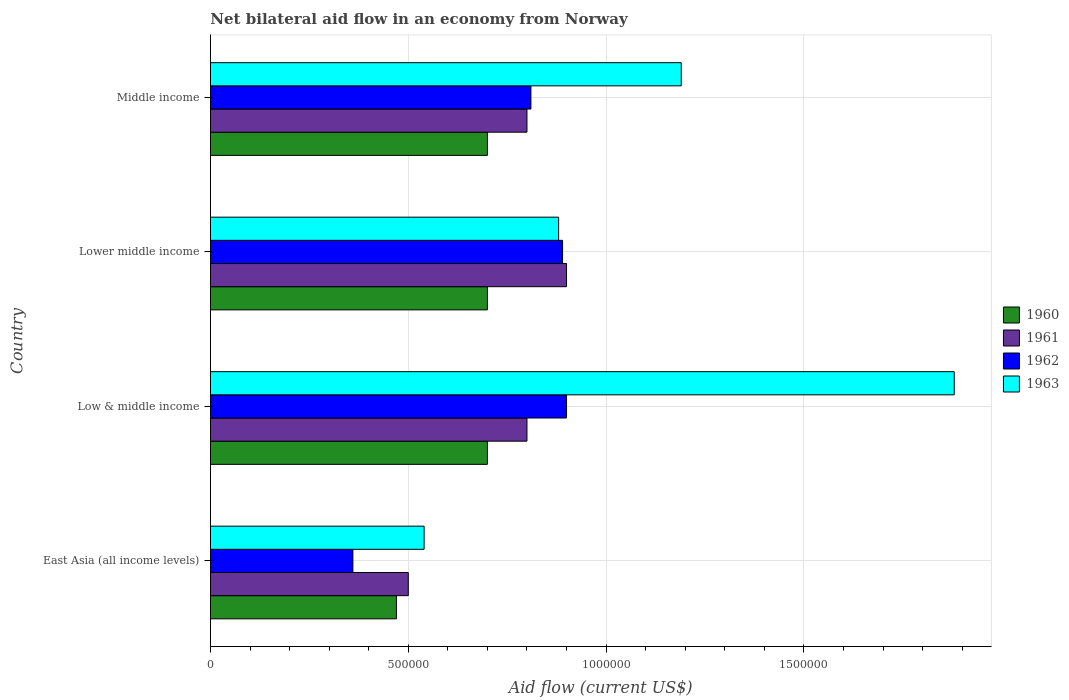How many groups of bars are there?
Offer a terse response. 4. How many bars are there on the 3rd tick from the top?
Ensure brevity in your answer.  4. What is the label of the 2nd group of bars from the top?
Provide a succinct answer. Lower middle income. In which country was the net bilateral aid flow in 1960 maximum?
Offer a terse response. Low & middle income. In which country was the net bilateral aid flow in 1960 minimum?
Give a very brief answer. East Asia (all income levels). What is the total net bilateral aid flow in 1960 in the graph?
Your response must be concise. 2.57e+06. What is the difference between the net bilateral aid flow in 1961 in East Asia (all income levels) and that in Middle income?
Give a very brief answer. -3.00e+05. What is the difference between the net bilateral aid flow in 1963 in Middle income and the net bilateral aid flow in 1961 in Low & middle income?
Offer a very short reply. 3.90e+05. What is the average net bilateral aid flow in 1960 per country?
Your answer should be compact. 6.42e+05. What is the difference between the net bilateral aid flow in 1960 and net bilateral aid flow in 1961 in Lower middle income?
Your answer should be very brief. -2.00e+05. What is the ratio of the net bilateral aid flow in 1963 in Low & middle income to that in Middle income?
Keep it short and to the point. 1.58. Is the difference between the net bilateral aid flow in 1960 in East Asia (all income levels) and Lower middle income greater than the difference between the net bilateral aid flow in 1961 in East Asia (all income levels) and Lower middle income?
Your response must be concise. Yes. What is the difference between the highest and the lowest net bilateral aid flow in 1961?
Make the answer very short. 4.00e+05. Is the sum of the net bilateral aid flow in 1963 in East Asia (all income levels) and Lower middle income greater than the maximum net bilateral aid flow in 1961 across all countries?
Offer a terse response. Yes. What does the 3rd bar from the top in East Asia (all income levels) represents?
Ensure brevity in your answer.  1961. Is it the case that in every country, the sum of the net bilateral aid flow in 1962 and net bilateral aid flow in 1963 is greater than the net bilateral aid flow in 1960?
Keep it short and to the point. Yes. How many bars are there?
Give a very brief answer. 16. How many countries are there in the graph?
Your answer should be compact. 4. Does the graph contain any zero values?
Ensure brevity in your answer.  No. Does the graph contain grids?
Offer a terse response. Yes. What is the title of the graph?
Your answer should be compact. Net bilateral aid flow in an economy from Norway. Does "2002" appear as one of the legend labels in the graph?
Provide a short and direct response. No. What is the label or title of the X-axis?
Give a very brief answer. Aid flow (current US$). What is the label or title of the Y-axis?
Keep it short and to the point. Country. What is the Aid flow (current US$) of 1962 in East Asia (all income levels)?
Offer a very short reply. 3.60e+05. What is the Aid flow (current US$) in 1963 in East Asia (all income levels)?
Give a very brief answer. 5.40e+05. What is the Aid flow (current US$) of 1961 in Low & middle income?
Offer a terse response. 8.00e+05. What is the Aid flow (current US$) of 1963 in Low & middle income?
Keep it short and to the point. 1.88e+06. What is the Aid flow (current US$) of 1960 in Lower middle income?
Make the answer very short. 7.00e+05. What is the Aid flow (current US$) in 1962 in Lower middle income?
Ensure brevity in your answer.  8.90e+05. What is the Aid flow (current US$) of 1963 in Lower middle income?
Your answer should be very brief. 8.80e+05. What is the Aid flow (current US$) in 1960 in Middle income?
Your response must be concise. 7.00e+05. What is the Aid flow (current US$) of 1962 in Middle income?
Offer a very short reply. 8.10e+05. What is the Aid flow (current US$) of 1963 in Middle income?
Offer a terse response. 1.19e+06. Across all countries, what is the maximum Aid flow (current US$) in 1962?
Provide a short and direct response. 9.00e+05. Across all countries, what is the maximum Aid flow (current US$) of 1963?
Provide a short and direct response. 1.88e+06. Across all countries, what is the minimum Aid flow (current US$) of 1961?
Provide a short and direct response. 5.00e+05. Across all countries, what is the minimum Aid flow (current US$) in 1963?
Your answer should be very brief. 5.40e+05. What is the total Aid flow (current US$) of 1960 in the graph?
Offer a terse response. 2.57e+06. What is the total Aid flow (current US$) of 1962 in the graph?
Your answer should be compact. 2.96e+06. What is the total Aid flow (current US$) in 1963 in the graph?
Give a very brief answer. 4.49e+06. What is the difference between the Aid flow (current US$) in 1961 in East Asia (all income levels) and that in Low & middle income?
Give a very brief answer. -3.00e+05. What is the difference between the Aid flow (current US$) of 1962 in East Asia (all income levels) and that in Low & middle income?
Give a very brief answer. -5.40e+05. What is the difference between the Aid flow (current US$) in 1963 in East Asia (all income levels) and that in Low & middle income?
Make the answer very short. -1.34e+06. What is the difference between the Aid flow (current US$) in 1960 in East Asia (all income levels) and that in Lower middle income?
Ensure brevity in your answer.  -2.30e+05. What is the difference between the Aid flow (current US$) in 1961 in East Asia (all income levels) and that in Lower middle income?
Give a very brief answer. -4.00e+05. What is the difference between the Aid flow (current US$) in 1962 in East Asia (all income levels) and that in Lower middle income?
Offer a terse response. -5.30e+05. What is the difference between the Aid flow (current US$) in 1963 in East Asia (all income levels) and that in Lower middle income?
Make the answer very short. -3.40e+05. What is the difference between the Aid flow (current US$) of 1962 in East Asia (all income levels) and that in Middle income?
Your answer should be compact. -4.50e+05. What is the difference between the Aid flow (current US$) of 1963 in East Asia (all income levels) and that in Middle income?
Make the answer very short. -6.50e+05. What is the difference between the Aid flow (current US$) in 1961 in Low & middle income and that in Lower middle income?
Your answer should be compact. -1.00e+05. What is the difference between the Aid flow (current US$) in 1962 in Low & middle income and that in Lower middle income?
Your response must be concise. 10000. What is the difference between the Aid flow (current US$) in 1963 in Low & middle income and that in Lower middle income?
Offer a very short reply. 1.00e+06. What is the difference between the Aid flow (current US$) of 1961 in Low & middle income and that in Middle income?
Make the answer very short. 0. What is the difference between the Aid flow (current US$) of 1963 in Low & middle income and that in Middle income?
Your answer should be compact. 6.90e+05. What is the difference between the Aid flow (current US$) of 1960 in Lower middle income and that in Middle income?
Keep it short and to the point. 0. What is the difference between the Aid flow (current US$) in 1961 in Lower middle income and that in Middle income?
Your answer should be compact. 1.00e+05. What is the difference between the Aid flow (current US$) of 1962 in Lower middle income and that in Middle income?
Provide a short and direct response. 8.00e+04. What is the difference between the Aid flow (current US$) in 1963 in Lower middle income and that in Middle income?
Provide a short and direct response. -3.10e+05. What is the difference between the Aid flow (current US$) in 1960 in East Asia (all income levels) and the Aid flow (current US$) in 1961 in Low & middle income?
Your answer should be compact. -3.30e+05. What is the difference between the Aid flow (current US$) of 1960 in East Asia (all income levels) and the Aid flow (current US$) of 1962 in Low & middle income?
Ensure brevity in your answer.  -4.30e+05. What is the difference between the Aid flow (current US$) in 1960 in East Asia (all income levels) and the Aid flow (current US$) in 1963 in Low & middle income?
Offer a terse response. -1.41e+06. What is the difference between the Aid flow (current US$) in 1961 in East Asia (all income levels) and the Aid flow (current US$) in 1962 in Low & middle income?
Your answer should be very brief. -4.00e+05. What is the difference between the Aid flow (current US$) in 1961 in East Asia (all income levels) and the Aid flow (current US$) in 1963 in Low & middle income?
Provide a succinct answer. -1.38e+06. What is the difference between the Aid flow (current US$) in 1962 in East Asia (all income levels) and the Aid flow (current US$) in 1963 in Low & middle income?
Provide a short and direct response. -1.52e+06. What is the difference between the Aid flow (current US$) of 1960 in East Asia (all income levels) and the Aid flow (current US$) of 1961 in Lower middle income?
Your answer should be compact. -4.30e+05. What is the difference between the Aid flow (current US$) of 1960 in East Asia (all income levels) and the Aid flow (current US$) of 1962 in Lower middle income?
Make the answer very short. -4.20e+05. What is the difference between the Aid flow (current US$) in 1960 in East Asia (all income levels) and the Aid flow (current US$) in 1963 in Lower middle income?
Your response must be concise. -4.10e+05. What is the difference between the Aid flow (current US$) of 1961 in East Asia (all income levels) and the Aid flow (current US$) of 1962 in Lower middle income?
Keep it short and to the point. -3.90e+05. What is the difference between the Aid flow (current US$) in 1961 in East Asia (all income levels) and the Aid flow (current US$) in 1963 in Lower middle income?
Your answer should be compact. -3.80e+05. What is the difference between the Aid flow (current US$) in 1962 in East Asia (all income levels) and the Aid flow (current US$) in 1963 in Lower middle income?
Your answer should be compact. -5.20e+05. What is the difference between the Aid flow (current US$) in 1960 in East Asia (all income levels) and the Aid flow (current US$) in 1961 in Middle income?
Offer a terse response. -3.30e+05. What is the difference between the Aid flow (current US$) in 1960 in East Asia (all income levels) and the Aid flow (current US$) in 1963 in Middle income?
Your answer should be very brief. -7.20e+05. What is the difference between the Aid flow (current US$) of 1961 in East Asia (all income levels) and the Aid flow (current US$) of 1962 in Middle income?
Your answer should be compact. -3.10e+05. What is the difference between the Aid flow (current US$) of 1961 in East Asia (all income levels) and the Aid flow (current US$) of 1963 in Middle income?
Offer a terse response. -6.90e+05. What is the difference between the Aid flow (current US$) of 1962 in East Asia (all income levels) and the Aid flow (current US$) of 1963 in Middle income?
Provide a succinct answer. -8.30e+05. What is the difference between the Aid flow (current US$) in 1960 in Low & middle income and the Aid flow (current US$) in 1961 in Lower middle income?
Offer a very short reply. -2.00e+05. What is the difference between the Aid flow (current US$) in 1960 in Low & middle income and the Aid flow (current US$) in 1963 in Lower middle income?
Your response must be concise. -1.80e+05. What is the difference between the Aid flow (current US$) of 1962 in Low & middle income and the Aid flow (current US$) of 1963 in Lower middle income?
Your answer should be very brief. 2.00e+04. What is the difference between the Aid flow (current US$) of 1960 in Low & middle income and the Aid flow (current US$) of 1962 in Middle income?
Offer a terse response. -1.10e+05. What is the difference between the Aid flow (current US$) of 1960 in Low & middle income and the Aid flow (current US$) of 1963 in Middle income?
Give a very brief answer. -4.90e+05. What is the difference between the Aid flow (current US$) of 1961 in Low & middle income and the Aid flow (current US$) of 1962 in Middle income?
Offer a terse response. -10000. What is the difference between the Aid flow (current US$) in 1961 in Low & middle income and the Aid flow (current US$) in 1963 in Middle income?
Provide a succinct answer. -3.90e+05. What is the difference between the Aid flow (current US$) of 1960 in Lower middle income and the Aid flow (current US$) of 1961 in Middle income?
Your answer should be compact. -1.00e+05. What is the difference between the Aid flow (current US$) of 1960 in Lower middle income and the Aid flow (current US$) of 1962 in Middle income?
Offer a very short reply. -1.10e+05. What is the difference between the Aid flow (current US$) in 1960 in Lower middle income and the Aid flow (current US$) in 1963 in Middle income?
Give a very brief answer. -4.90e+05. What is the difference between the Aid flow (current US$) in 1961 in Lower middle income and the Aid flow (current US$) in 1963 in Middle income?
Provide a short and direct response. -2.90e+05. What is the difference between the Aid flow (current US$) of 1962 in Lower middle income and the Aid flow (current US$) of 1963 in Middle income?
Provide a short and direct response. -3.00e+05. What is the average Aid flow (current US$) in 1960 per country?
Provide a short and direct response. 6.42e+05. What is the average Aid flow (current US$) of 1961 per country?
Your answer should be very brief. 7.50e+05. What is the average Aid flow (current US$) of 1962 per country?
Keep it short and to the point. 7.40e+05. What is the average Aid flow (current US$) of 1963 per country?
Offer a very short reply. 1.12e+06. What is the difference between the Aid flow (current US$) of 1960 and Aid flow (current US$) of 1961 in East Asia (all income levels)?
Give a very brief answer. -3.00e+04. What is the difference between the Aid flow (current US$) in 1960 and Aid flow (current US$) in 1963 in East Asia (all income levels)?
Provide a succinct answer. -7.00e+04. What is the difference between the Aid flow (current US$) of 1961 and Aid flow (current US$) of 1962 in East Asia (all income levels)?
Provide a succinct answer. 1.40e+05. What is the difference between the Aid flow (current US$) in 1961 and Aid flow (current US$) in 1963 in East Asia (all income levels)?
Offer a terse response. -4.00e+04. What is the difference between the Aid flow (current US$) in 1962 and Aid flow (current US$) in 1963 in East Asia (all income levels)?
Make the answer very short. -1.80e+05. What is the difference between the Aid flow (current US$) of 1960 and Aid flow (current US$) of 1961 in Low & middle income?
Provide a short and direct response. -1.00e+05. What is the difference between the Aid flow (current US$) of 1960 and Aid flow (current US$) of 1963 in Low & middle income?
Offer a very short reply. -1.18e+06. What is the difference between the Aid flow (current US$) in 1961 and Aid flow (current US$) in 1963 in Low & middle income?
Ensure brevity in your answer.  -1.08e+06. What is the difference between the Aid flow (current US$) of 1962 and Aid flow (current US$) of 1963 in Low & middle income?
Ensure brevity in your answer.  -9.80e+05. What is the difference between the Aid flow (current US$) of 1961 and Aid flow (current US$) of 1962 in Lower middle income?
Ensure brevity in your answer.  10000. What is the difference between the Aid flow (current US$) of 1962 and Aid flow (current US$) of 1963 in Lower middle income?
Provide a succinct answer. 10000. What is the difference between the Aid flow (current US$) in 1960 and Aid flow (current US$) in 1962 in Middle income?
Make the answer very short. -1.10e+05. What is the difference between the Aid flow (current US$) in 1960 and Aid flow (current US$) in 1963 in Middle income?
Make the answer very short. -4.90e+05. What is the difference between the Aid flow (current US$) of 1961 and Aid flow (current US$) of 1963 in Middle income?
Ensure brevity in your answer.  -3.90e+05. What is the difference between the Aid flow (current US$) of 1962 and Aid flow (current US$) of 1963 in Middle income?
Ensure brevity in your answer.  -3.80e+05. What is the ratio of the Aid flow (current US$) in 1960 in East Asia (all income levels) to that in Low & middle income?
Your answer should be compact. 0.67. What is the ratio of the Aid flow (current US$) in 1961 in East Asia (all income levels) to that in Low & middle income?
Ensure brevity in your answer.  0.62. What is the ratio of the Aid flow (current US$) in 1963 in East Asia (all income levels) to that in Low & middle income?
Ensure brevity in your answer.  0.29. What is the ratio of the Aid flow (current US$) of 1960 in East Asia (all income levels) to that in Lower middle income?
Offer a terse response. 0.67. What is the ratio of the Aid flow (current US$) in 1961 in East Asia (all income levels) to that in Lower middle income?
Make the answer very short. 0.56. What is the ratio of the Aid flow (current US$) of 1962 in East Asia (all income levels) to that in Lower middle income?
Your answer should be compact. 0.4. What is the ratio of the Aid flow (current US$) in 1963 in East Asia (all income levels) to that in Lower middle income?
Your answer should be compact. 0.61. What is the ratio of the Aid flow (current US$) in 1960 in East Asia (all income levels) to that in Middle income?
Make the answer very short. 0.67. What is the ratio of the Aid flow (current US$) of 1962 in East Asia (all income levels) to that in Middle income?
Your response must be concise. 0.44. What is the ratio of the Aid flow (current US$) of 1963 in East Asia (all income levels) to that in Middle income?
Offer a very short reply. 0.45. What is the ratio of the Aid flow (current US$) in 1962 in Low & middle income to that in Lower middle income?
Your answer should be very brief. 1.01. What is the ratio of the Aid flow (current US$) of 1963 in Low & middle income to that in Lower middle income?
Offer a very short reply. 2.14. What is the ratio of the Aid flow (current US$) in 1960 in Low & middle income to that in Middle income?
Give a very brief answer. 1. What is the ratio of the Aid flow (current US$) in 1961 in Low & middle income to that in Middle income?
Your answer should be compact. 1. What is the ratio of the Aid flow (current US$) of 1962 in Low & middle income to that in Middle income?
Keep it short and to the point. 1.11. What is the ratio of the Aid flow (current US$) in 1963 in Low & middle income to that in Middle income?
Make the answer very short. 1.58. What is the ratio of the Aid flow (current US$) in 1962 in Lower middle income to that in Middle income?
Offer a very short reply. 1.1. What is the ratio of the Aid flow (current US$) in 1963 in Lower middle income to that in Middle income?
Offer a terse response. 0.74. What is the difference between the highest and the second highest Aid flow (current US$) of 1960?
Your response must be concise. 0. What is the difference between the highest and the second highest Aid flow (current US$) in 1963?
Your answer should be very brief. 6.90e+05. What is the difference between the highest and the lowest Aid flow (current US$) in 1960?
Provide a short and direct response. 2.30e+05. What is the difference between the highest and the lowest Aid flow (current US$) in 1961?
Your answer should be compact. 4.00e+05. What is the difference between the highest and the lowest Aid flow (current US$) of 1962?
Your answer should be very brief. 5.40e+05. What is the difference between the highest and the lowest Aid flow (current US$) of 1963?
Your response must be concise. 1.34e+06. 